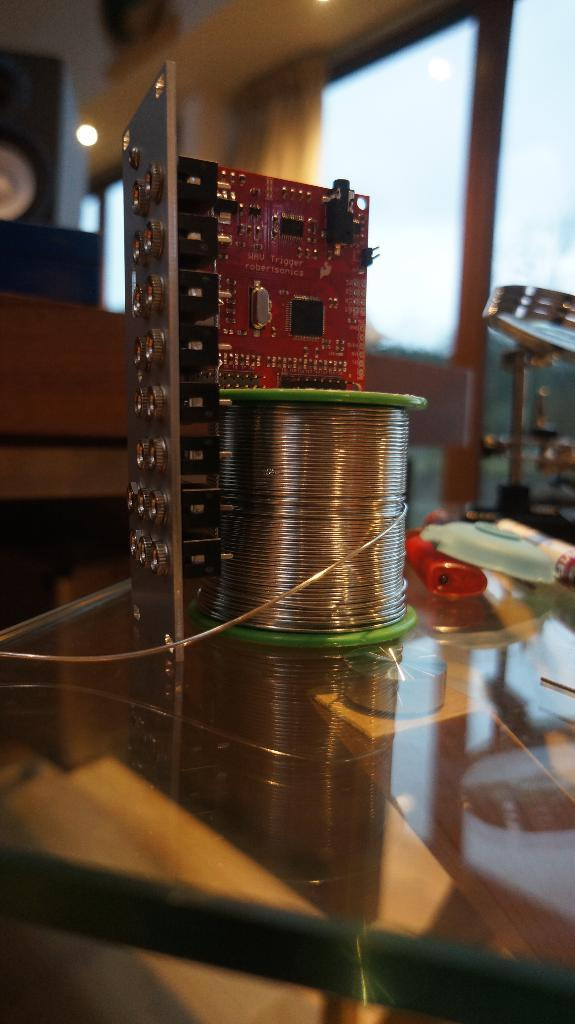What is the main object in the image? There is a table in the image. What is on the table? Papers and wires are present on the table. What can be seen in the background of the image? There is a wall and a window in the background of the image. What type of insurance policy is being discussed at the zoo in the image? There is no zoo or insurance policy discussion present in the image. The image only shows a table with papers and wires, and a wall and window in the background. 